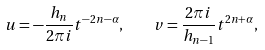<formula> <loc_0><loc_0><loc_500><loc_500>u = - \frac { h _ { n } } { 2 \pi i } t ^ { - 2 n - \alpha } , \quad v = \frac { 2 \pi i } { h _ { n - 1 } } t ^ { 2 n + \alpha } ,</formula> 